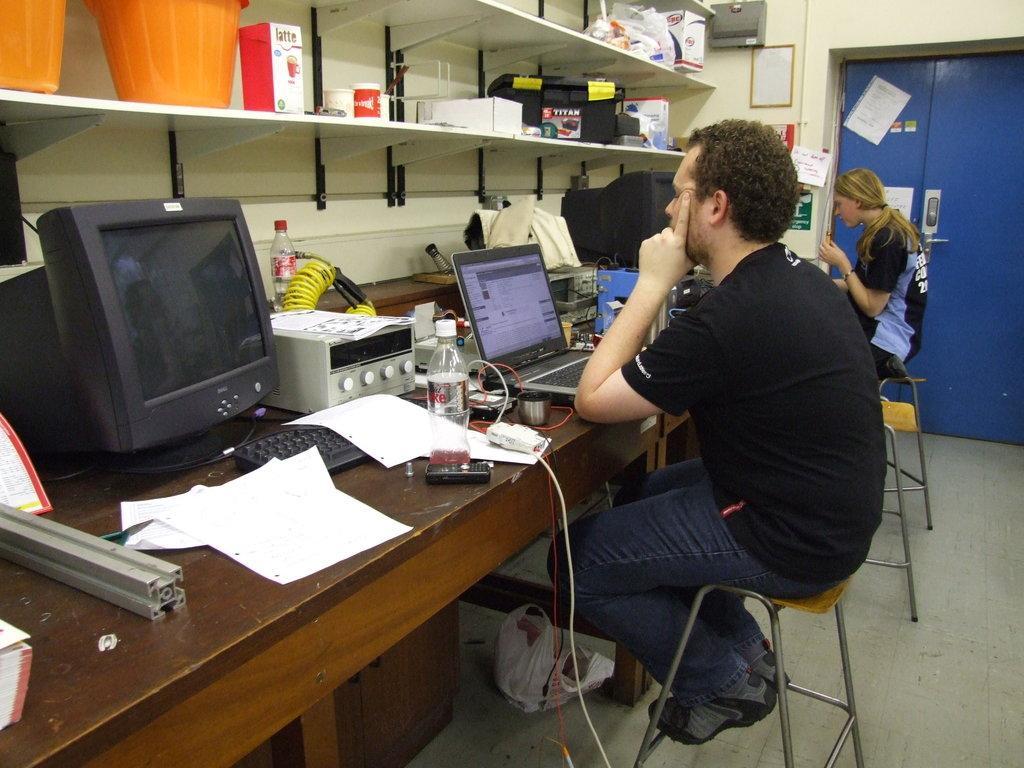Could you give a brief overview of what you see in this image? There are two persons sitting on a stool and there is a table in front of them which has laptops,desktops and some other objects on it. 